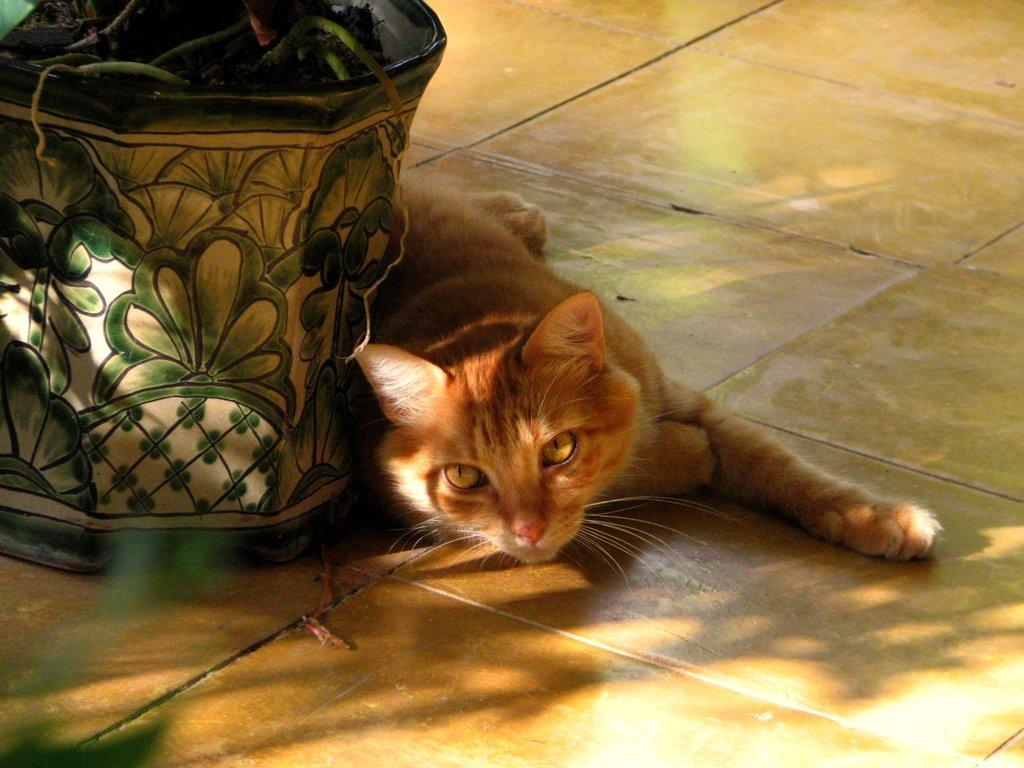What type of animal is in the image? There is a cat in the image. Where is the cat located in the image? The cat is on the floor. What else can be seen in the image besides the cat? There is a plant in a pot in the image. Is the cat getting a haircut in the image? No, there is no indication in the image that the cat is getting a haircut. Is the cat walking on a snow-covered street in the image? No, the image does not show a snow-covered street or any indication of the cat walking. 